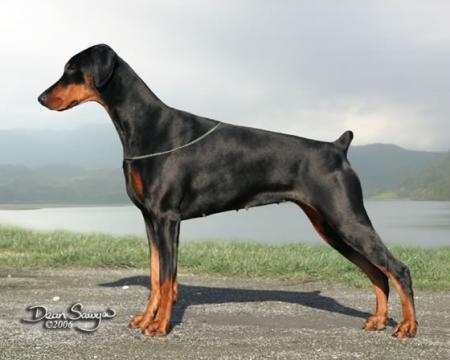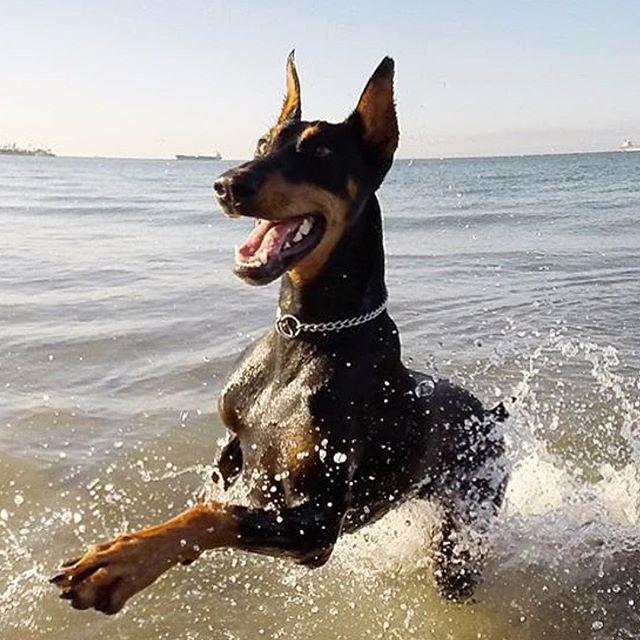The first image is the image on the left, the second image is the image on the right. For the images displayed, is the sentence "A doberman has its mouth open." factually correct? Answer yes or no. Yes. The first image is the image on the left, the second image is the image on the right. Considering the images on both sides, is "All dogs shown have erect ears, each image contains one dog, the dog on the left is sitting upright, and the dog on the right is standing angled rightward." valid? Answer yes or no. No. 